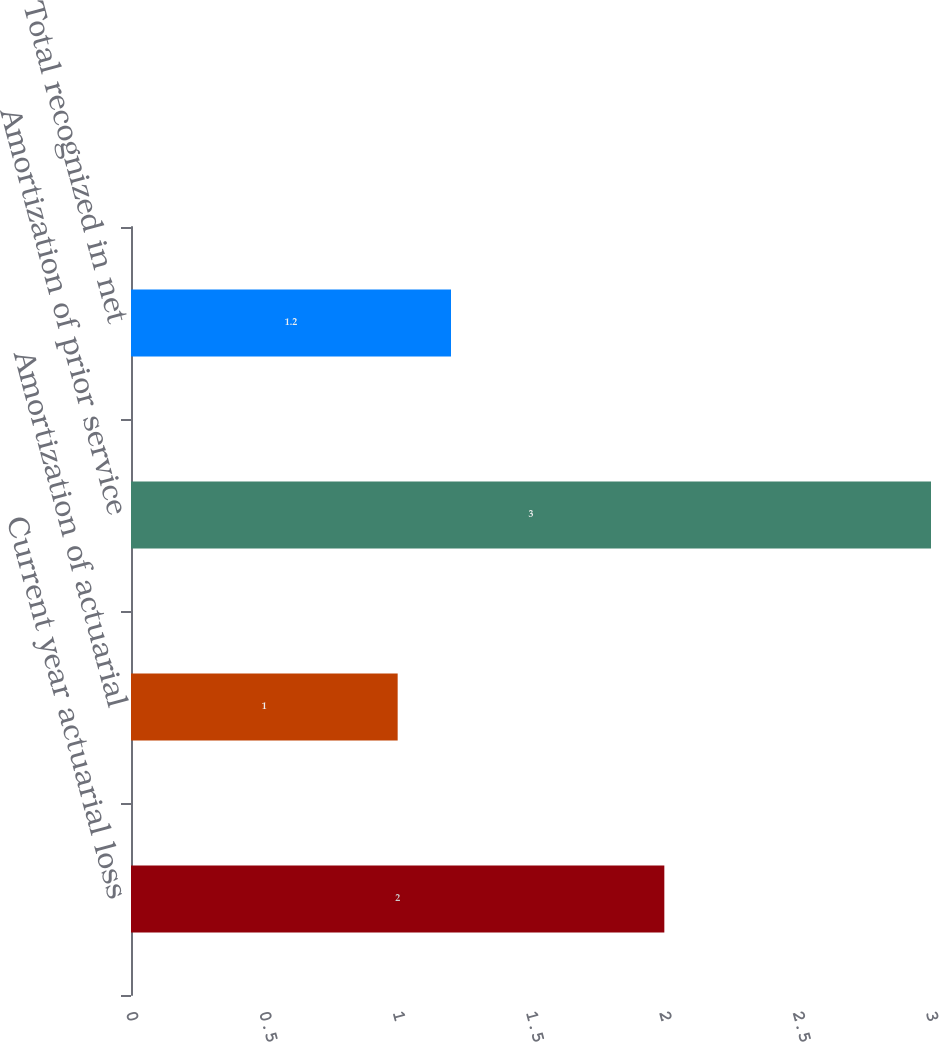<chart> <loc_0><loc_0><loc_500><loc_500><bar_chart><fcel>Current year actuarial loss<fcel>Amortization of actuarial<fcel>Amortization of prior service<fcel>Total recognized in net<nl><fcel>2<fcel>1<fcel>3<fcel>1.2<nl></chart> 